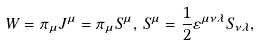<formula> <loc_0><loc_0><loc_500><loc_500>W = \pi _ { \mu } J ^ { \mu } = \pi _ { \mu } S ^ { \mu } , \, S ^ { \mu } = \frac { 1 } { 2 } \varepsilon ^ { \mu \nu \lambda } S _ { \nu \lambda } ,</formula> 